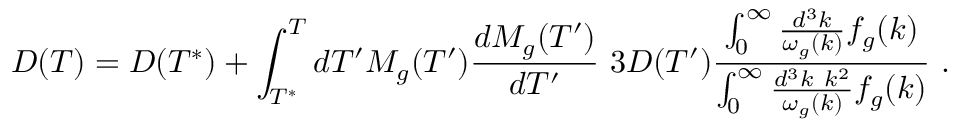<formula> <loc_0><loc_0><loc_500><loc_500>D ( T ) = D ( T ^ { * } ) + \int _ { T ^ { * } } ^ { T } d T ^ { \prime } M _ { g } ( T ^ { \prime } ) \frac { d M _ { g } ( T ^ { \prime } ) } { d T ^ { \prime } } \ 3 D ( T ^ { \prime } ) { \frac { \int _ { 0 } ^ { \infty } \frac { d ^ { 3 } k } { \omega _ { g } ( k ) } f _ { g } ( k ) } { \int _ { 0 } ^ { \infty } \frac { d ^ { 3 } k k ^ { 2 } } { \omega _ { g } ( k ) } f _ { g } ( k ) } } \ .</formula> 